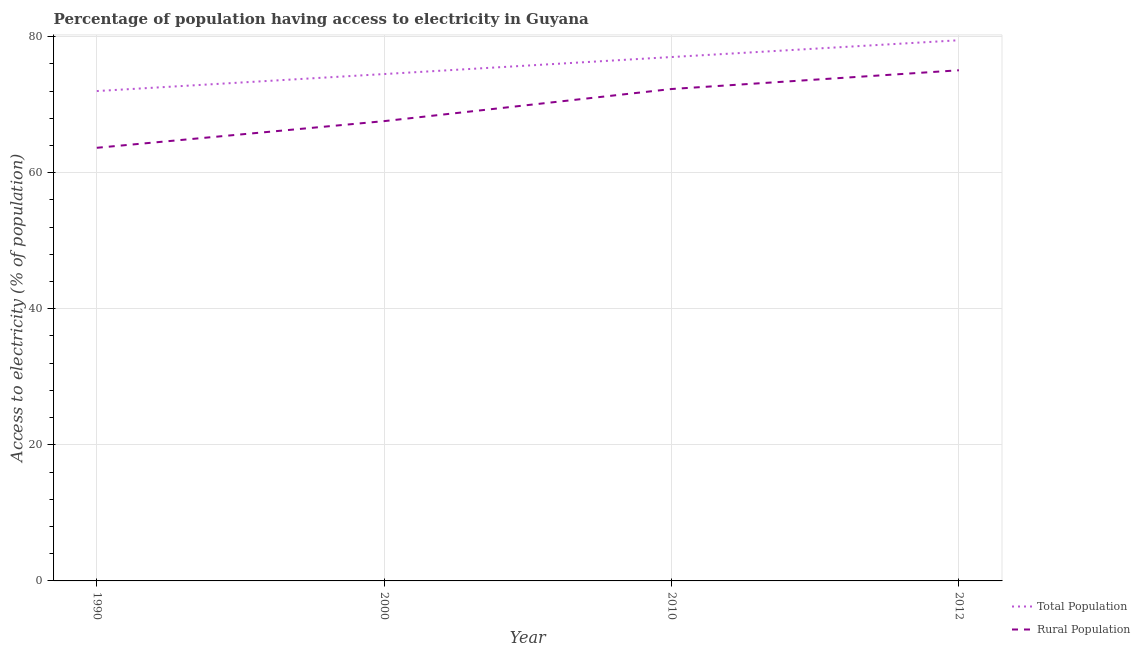How many different coloured lines are there?
Provide a short and direct response. 2. Is the number of lines equal to the number of legend labels?
Keep it short and to the point. Yes. What is the percentage of rural population having access to electricity in 2012?
Your response must be concise. 75.05. Across all years, what is the maximum percentage of rural population having access to electricity?
Provide a short and direct response. 75.05. Across all years, what is the minimum percentage of population having access to electricity?
Keep it short and to the point. 72. In which year was the percentage of population having access to electricity maximum?
Provide a short and direct response. 2012. In which year was the percentage of population having access to electricity minimum?
Give a very brief answer. 1990. What is the total percentage of population having access to electricity in the graph?
Make the answer very short. 302.97. What is the difference between the percentage of population having access to electricity in 2000 and that in 2012?
Make the answer very short. -4.97. What is the difference between the percentage of rural population having access to electricity in 2010 and the percentage of population having access to electricity in 2012?
Provide a short and direct response. -7.17. What is the average percentage of rural population having access to electricity per year?
Your answer should be compact. 69.65. In the year 1990, what is the difference between the percentage of rural population having access to electricity and percentage of population having access to electricity?
Ensure brevity in your answer.  -8.34. In how many years, is the percentage of rural population having access to electricity greater than 68 %?
Make the answer very short. 2. What is the ratio of the percentage of population having access to electricity in 1990 to that in 2010?
Ensure brevity in your answer.  0.94. Is the percentage of rural population having access to electricity in 2010 less than that in 2012?
Your response must be concise. Yes. Is the difference between the percentage of population having access to electricity in 1990 and 2000 greater than the difference between the percentage of rural population having access to electricity in 1990 and 2000?
Make the answer very short. Yes. What is the difference between the highest and the second highest percentage of rural population having access to electricity?
Your answer should be compact. 2.75. What is the difference between the highest and the lowest percentage of population having access to electricity?
Ensure brevity in your answer.  7.47. Does the percentage of population having access to electricity monotonically increase over the years?
Make the answer very short. Yes. Is the percentage of population having access to electricity strictly greater than the percentage of rural population having access to electricity over the years?
Offer a very short reply. Yes. How many lines are there?
Keep it short and to the point. 2. What is the difference between two consecutive major ticks on the Y-axis?
Your answer should be very brief. 20. Where does the legend appear in the graph?
Offer a terse response. Bottom right. How many legend labels are there?
Offer a terse response. 2. What is the title of the graph?
Ensure brevity in your answer.  Percentage of population having access to electricity in Guyana. What is the label or title of the Y-axis?
Ensure brevity in your answer.  Access to electricity (% of population). What is the Access to electricity (% of population) of Total Population in 1990?
Make the answer very short. 72. What is the Access to electricity (% of population) in Rural Population in 1990?
Your answer should be compact. 63.66. What is the Access to electricity (% of population) of Total Population in 2000?
Offer a very short reply. 74.5. What is the Access to electricity (% of population) in Rural Population in 2000?
Make the answer very short. 67.58. What is the Access to electricity (% of population) in Total Population in 2010?
Make the answer very short. 77. What is the Access to electricity (% of population) of Rural Population in 2010?
Ensure brevity in your answer.  72.3. What is the Access to electricity (% of population) of Total Population in 2012?
Offer a terse response. 79.47. What is the Access to electricity (% of population) in Rural Population in 2012?
Provide a succinct answer. 75.05. Across all years, what is the maximum Access to electricity (% of population) in Total Population?
Provide a short and direct response. 79.47. Across all years, what is the maximum Access to electricity (% of population) in Rural Population?
Your answer should be very brief. 75.05. Across all years, what is the minimum Access to electricity (% of population) of Rural Population?
Your answer should be very brief. 63.66. What is the total Access to electricity (% of population) in Total Population in the graph?
Your answer should be very brief. 302.97. What is the total Access to electricity (% of population) in Rural Population in the graph?
Make the answer very short. 278.6. What is the difference between the Access to electricity (% of population) in Total Population in 1990 and that in 2000?
Offer a very short reply. -2.5. What is the difference between the Access to electricity (% of population) in Rural Population in 1990 and that in 2000?
Your response must be concise. -3.92. What is the difference between the Access to electricity (% of population) in Total Population in 1990 and that in 2010?
Your answer should be compact. -5. What is the difference between the Access to electricity (% of population) in Rural Population in 1990 and that in 2010?
Provide a short and direct response. -8.64. What is the difference between the Access to electricity (% of population) of Total Population in 1990 and that in 2012?
Keep it short and to the point. -7.47. What is the difference between the Access to electricity (% of population) of Rural Population in 1990 and that in 2012?
Your answer should be very brief. -11.39. What is the difference between the Access to electricity (% of population) of Total Population in 2000 and that in 2010?
Your answer should be very brief. -2.5. What is the difference between the Access to electricity (% of population) in Rural Population in 2000 and that in 2010?
Your response must be concise. -4.72. What is the difference between the Access to electricity (% of population) of Total Population in 2000 and that in 2012?
Your answer should be compact. -4.97. What is the difference between the Access to electricity (% of population) in Rural Population in 2000 and that in 2012?
Your response must be concise. -7.47. What is the difference between the Access to electricity (% of population) in Total Population in 2010 and that in 2012?
Offer a terse response. -2.47. What is the difference between the Access to electricity (% of population) in Rural Population in 2010 and that in 2012?
Make the answer very short. -2.75. What is the difference between the Access to electricity (% of population) of Total Population in 1990 and the Access to electricity (% of population) of Rural Population in 2000?
Your response must be concise. 4.42. What is the difference between the Access to electricity (% of population) in Total Population in 1990 and the Access to electricity (% of population) in Rural Population in 2012?
Your response must be concise. -3.05. What is the difference between the Access to electricity (% of population) of Total Population in 2000 and the Access to electricity (% of population) of Rural Population in 2012?
Offer a very short reply. -0.55. What is the difference between the Access to electricity (% of population) of Total Population in 2010 and the Access to electricity (% of population) of Rural Population in 2012?
Keep it short and to the point. 1.95. What is the average Access to electricity (% of population) of Total Population per year?
Make the answer very short. 75.74. What is the average Access to electricity (% of population) of Rural Population per year?
Your answer should be compact. 69.65. In the year 1990, what is the difference between the Access to electricity (% of population) in Total Population and Access to electricity (% of population) in Rural Population?
Your response must be concise. 8.34. In the year 2000, what is the difference between the Access to electricity (% of population) in Total Population and Access to electricity (% of population) in Rural Population?
Offer a very short reply. 6.92. In the year 2010, what is the difference between the Access to electricity (% of population) of Total Population and Access to electricity (% of population) of Rural Population?
Your answer should be compact. 4.7. In the year 2012, what is the difference between the Access to electricity (% of population) in Total Population and Access to electricity (% of population) in Rural Population?
Offer a terse response. 4.41. What is the ratio of the Access to electricity (% of population) in Total Population in 1990 to that in 2000?
Offer a terse response. 0.97. What is the ratio of the Access to electricity (% of population) of Rural Population in 1990 to that in 2000?
Offer a very short reply. 0.94. What is the ratio of the Access to electricity (% of population) in Total Population in 1990 to that in 2010?
Keep it short and to the point. 0.94. What is the ratio of the Access to electricity (% of population) in Rural Population in 1990 to that in 2010?
Offer a terse response. 0.88. What is the ratio of the Access to electricity (% of population) in Total Population in 1990 to that in 2012?
Your response must be concise. 0.91. What is the ratio of the Access to electricity (% of population) of Rural Population in 1990 to that in 2012?
Offer a terse response. 0.85. What is the ratio of the Access to electricity (% of population) of Total Population in 2000 to that in 2010?
Give a very brief answer. 0.97. What is the ratio of the Access to electricity (% of population) in Rural Population in 2000 to that in 2010?
Provide a short and direct response. 0.93. What is the ratio of the Access to electricity (% of population) in Total Population in 2000 to that in 2012?
Provide a succinct answer. 0.94. What is the ratio of the Access to electricity (% of population) in Rural Population in 2000 to that in 2012?
Offer a very short reply. 0.9. What is the ratio of the Access to electricity (% of population) of Rural Population in 2010 to that in 2012?
Offer a terse response. 0.96. What is the difference between the highest and the second highest Access to electricity (% of population) of Total Population?
Your answer should be very brief. 2.47. What is the difference between the highest and the second highest Access to electricity (% of population) of Rural Population?
Your answer should be very brief. 2.75. What is the difference between the highest and the lowest Access to electricity (% of population) of Total Population?
Give a very brief answer. 7.47. What is the difference between the highest and the lowest Access to electricity (% of population) in Rural Population?
Give a very brief answer. 11.39. 